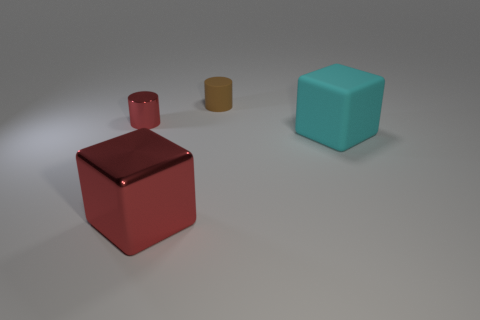Add 4 small cyan matte balls. How many objects exist? 8 Add 3 yellow blocks. How many yellow blocks exist? 3 Subtract 0 gray cylinders. How many objects are left? 4 Subtract all cyan cubes. Subtract all blocks. How many objects are left? 1 Add 4 big rubber objects. How many big rubber objects are left? 5 